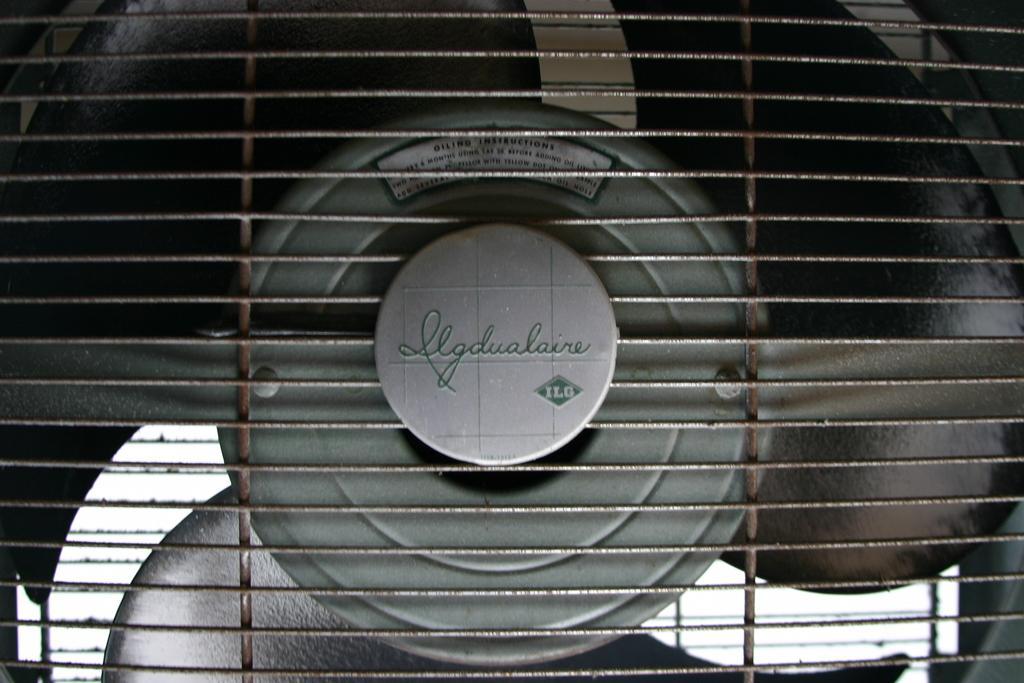Describe this image in one or two sentences. This picture shows a fan and we see grill and we see some text on it. 